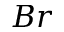<formula> <loc_0><loc_0><loc_500><loc_500>B r</formula> 